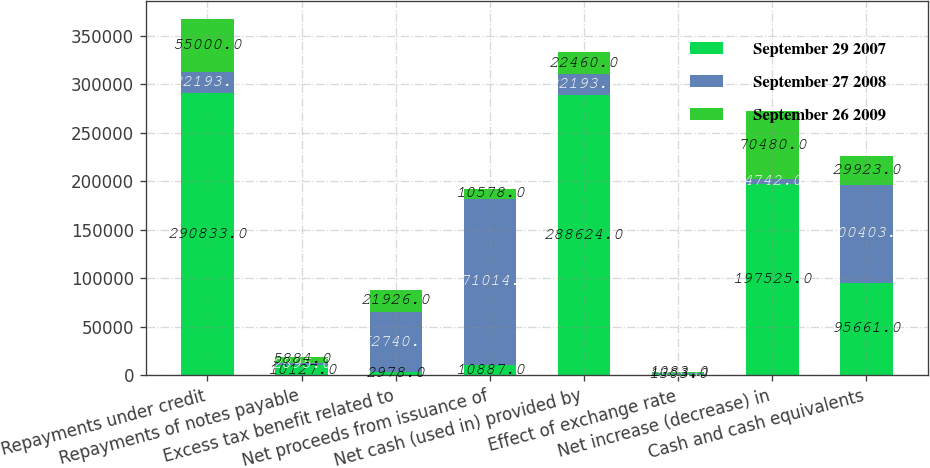<chart> <loc_0><loc_0><loc_500><loc_500><stacked_bar_chart><ecel><fcel>Repayments under credit<fcel>Repayments of notes payable<fcel>Excess tax benefit related to<fcel>Net proceeds from issuance of<fcel>Net cash (used in) provided by<fcel>Effect of exchange rate<fcel>Net increase (decrease) in<fcel>Cash and cash equivalents<nl><fcel>September 29 2007<fcel>290833<fcel>10127<fcel>2978<fcel>10887<fcel>288624<fcel>1303<fcel>197525<fcel>95661<nl><fcel>September 27 2008<fcel>22193<fcel>2895<fcel>62740<fcel>171014<fcel>22193<fcel>968<fcel>4742<fcel>100403<nl><fcel>September 26 2009<fcel>55000<fcel>5884<fcel>21926<fcel>10578<fcel>22460<fcel>1083<fcel>70480<fcel>29923<nl></chart> 